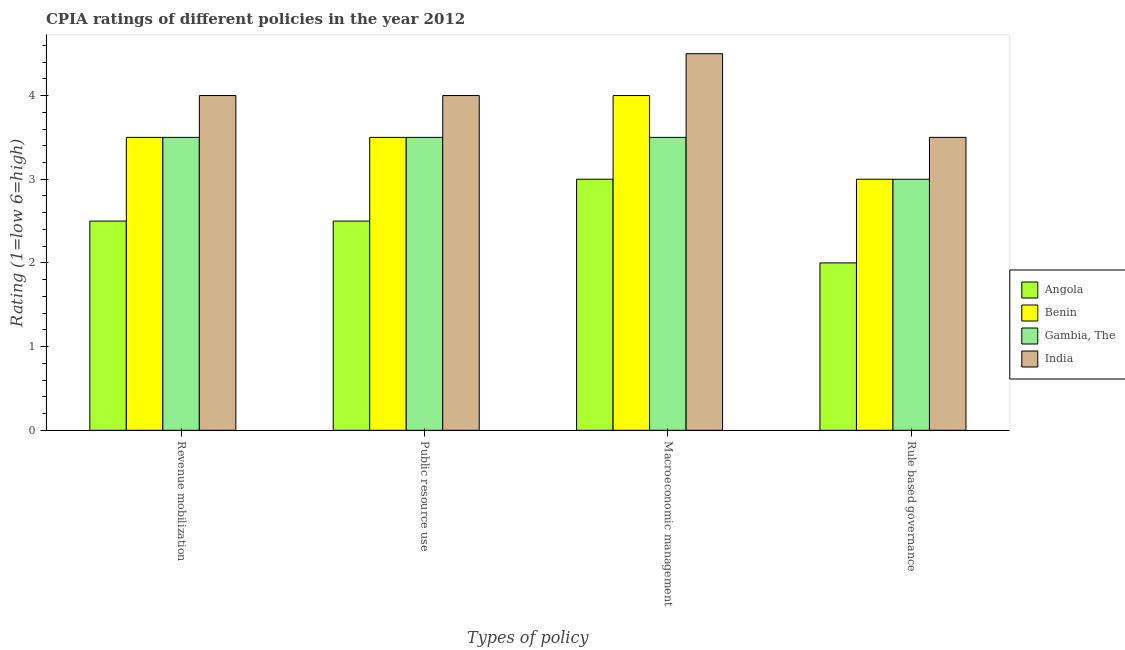How many groups of bars are there?
Your answer should be compact. 4. Are the number of bars on each tick of the X-axis equal?
Keep it short and to the point. Yes. How many bars are there on the 2nd tick from the right?
Ensure brevity in your answer.  4. What is the label of the 3rd group of bars from the left?
Make the answer very short. Macroeconomic management. Across all countries, what is the maximum cpia rating of rule based governance?
Offer a terse response. 3.5. Across all countries, what is the minimum cpia rating of macroeconomic management?
Keep it short and to the point. 3. In which country was the cpia rating of revenue mobilization maximum?
Ensure brevity in your answer.  India. In which country was the cpia rating of public resource use minimum?
Your response must be concise. Angola. What is the total cpia rating of public resource use in the graph?
Offer a terse response. 13.5. What is the difference between the cpia rating of macroeconomic management in India and that in Benin?
Offer a very short reply. 0.5. What is the average cpia rating of public resource use per country?
Ensure brevity in your answer.  3.38. What is the difference between the cpia rating of rule based governance and cpia rating of public resource use in Gambia, The?
Make the answer very short. -0.5. In how many countries, is the cpia rating of macroeconomic management greater than 1.6 ?
Keep it short and to the point. 4. What is the ratio of the cpia rating of rule based governance in India to that in Angola?
Your response must be concise. 1.75. Is the cpia rating of rule based governance in Angola less than that in Benin?
Ensure brevity in your answer.  Yes. Is the difference between the cpia rating of revenue mobilization in India and Benin greater than the difference between the cpia rating of macroeconomic management in India and Benin?
Provide a succinct answer. No. What is the difference between the highest and the second highest cpia rating of rule based governance?
Keep it short and to the point. 0.5. What is the difference between the highest and the lowest cpia rating of revenue mobilization?
Make the answer very short. 1.5. Is the sum of the cpia rating of rule based governance in India and Angola greater than the maximum cpia rating of revenue mobilization across all countries?
Offer a terse response. Yes. What does the 3rd bar from the left in Macroeconomic management represents?
Your response must be concise. Gambia, The. What does the 1st bar from the right in Rule based governance represents?
Provide a short and direct response. India. Is it the case that in every country, the sum of the cpia rating of revenue mobilization and cpia rating of public resource use is greater than the cpia rating of macroeconomic management?
Your answer should be compact. Yes. How many bars are there?
Provide a succinct answer. 16. What is the difference between two consecutive major ticks on the Y-axis?
Ensure brevity in your answer.  1. Does the graph contain any zero values?
Provide a short and direct response. No. Does the graph contain grids?
Provide a short and direct response. No. How many legend labels are there?
Provide a succinct answer. 4. How are the legend labels stacked?
Give a very brief answer. Vertical. What is the title of the graph?
Make the answer very short. CPIA ratings of different policies in the year 2012. What is the label or title of the X-axis?
Provide a succinct answer. Types of policy. What is the label or title of the Y-axis?
Give a very brief answer. Rating (1=low 6=high). What is the Rating (1=low 6=high) in Angola in Revenue mobilization?
Your answer should be compact. 2.5. What is the Rating (1=low 6=high) in Gambia, The in Revenue mobilization?
Ensure brevity in your answer.  3.5. What is the Rating (1=low 6=high) in Angola in Public resource use?
Your answer should be compact. 2.5. What is the Rating (1=low 6=high) of Benin in Public resource use?
Your answer should be very brief. 3.5. What is the Rating (1=low 6=high) of Gambia, The in Macroeconomic management?
Keep it short and to the point. 3.5. What is the Rating (1=low 6=high) of Benin in Rule based governance?
Offer a very short reply. 3. What is the Rating (1=low 6=high) of Gambia, The in Rule based governance?
Give a very brief answer. 3. Across all Types of policy, what is the maximum Rating (1=low 6=high) of Benin?
Give a very brief answer. 4. Across all Types of policy, what is the maximum Rating (1=low 6=high) in India?
Provide a short and direct response. 4.5. Across all Types of policy, what is the minimum Rating (1=low 6=high) in Benin?
Keep it short and to the point. 3. What is the total Rating (1=low 6=high) of Angola in the graph?
Offer a very short reply. 10. What is the total Rating (1=low 6=high) of Benin in the graph?
Give a very brief answer. 14. What is the total Rating (1=low 6=high) in Gambia, The in the graph?
Make the answer very short. 13.5. What is the difference between the Rating (1=low 6=high) in India in Revenue mobilization and that in Macroeconomic management?
Keep it short and to the point. -0.5. What is the difference between the Rating (1=low 6=high) in Gambia, The in Revenue mobilization and that in Rule based governance?
Your answer should be very brief. 0.5. What is the difference between the Rating (1=low 6=high) in India in Public resource use and that in Macroeconomic management?
Ensure brevity in your answer.  -0.5. What is the difference between the Rating (1=low 6=high) of Benin in Public resource use and that in Rule based governance?
Make the answer very short. 0.5. What is the difference between the Rating (1=low 6=high) in Gambia, The in Public resource use and that in Rule based governance?
Make the answer very short. 0.5. What is the difference between the Rating (1=low 6=high) in India in Public resource use and that in Rule based governance?
Provide a short and direct response. 0.5. What is the difference between the Rating (1=low 6=high) of Benin in Macroeconomic management and that in Rule based governance?
Your answer should be very brief. 1. What is the difference between the Rating (1=low 6=high) of Gambia, The in Macroeconomic management and that in Rule based governance?
Your answer should be very brief. 0.5. What is the difference between the Rating (1=low 6=high) in Angola in Revenue mobilization and the Rating (1=low 6=high) in Gambia, The in Public resource use?
Your response must be concise. -1. What is the difference between the Rating (1=low 6=high) in Benin in Revenue mobilization and the Rating (1=low 6=high) in Gambia, The in Public resource use?
Your answer should be compact. 0. What is the difference between the Rating (1=low 6=high) in Benin in Revenue mobilization and the Rating (1=low 6=high) in India in Public resource use?
Ensure brevity in your answer.  -0.5. What is the difference between the Rating (1=low 6=high) in Benin in Revenue mobilization and the Rating (1=low 6=high) in India in Macroeconomic management?
Offer a very short reply. -1. What is the difference between the Rating (1=low 6=high) of Angola in Revenue mobilization and the Rating (1=low 6=high) of Benin in Rule based governance?
Your response must be concise. -0.5. What is the difference between the Rating (1=low 6=high) of Benin in Revenue mobilization and the Rating (1=low 6=high) of Gambia, The in Rule based governance?
Give a very brief answer. 0.5. What is the difference between the Rating (1=low 6=high) in Angola in Public resource use and the Rating (1=low 6=high) in Benin in Macroeconomic management?
Offer a very short reply. -1.5. What is the difference between the Rating (1=low 6=high) in Angola in Public resource use and the Rating (1=low 6=high) in Gambia, The in Macroeconomic management?
Your answer should be compact. -1. What is the difference between the Rating (1=low 6=high) in Angola in Public resource use and the Rating (1=low 6=high) in India in Macroeconomic management?
Your answer should be very brief. -2. What is the difference between the Rating (1=low 6=high) in Angola in Public resource use and the Rating (1=low 6=high) in Gambia, The in Rule based governance?
Ensure brevity in your answer.  -0.5. What is the difference between the Rating (1=low 6=high) of Benin in Public resource use and the Rating (1=low 6=high) of Gambia, The in Rule based governance?
Offer a terse response. 0.5. What is the difference between the Rating (1=low 6=high) in Benin in Public resource use and the Rating (1=low 6=high) in India in Rule based governance?
Provide a succinct answer. 0. What is the difference between the Rating (1=low 6=high) of Gambia, The in Public resource use and the Rating (1=low 6=high) of India in Rule based governance?
Ensure brevity in your answer.  0. What is the difference between the Rating (1=low 6=high) of Angola in Macroeconomic management and the Rating (1=low 6=high) of Gambia, The in Rule based governance?
Offer a very short reply. 0. What is the difference between the Rating (1=low 6=high) in Benin in Macroeconomic management and the Rating (1=low 6=high) in Gambia, The in Rule based governance?
Give a very brief answer. 1. What is the average Rating (1=low 6=high) in Angola per Types of policy?
Make the answer very short. 2.5. What is the average Rating (1=low 6=high) in Gambia, The per Types of policy?
Ensure brevity in your answer.  3.38. What is the average Rating (1=low 6=high) of India per Types of policy?
Your response must be concise. 4. What is the difference between the Rating (1=low 6=high) of Angola and Rating (1=low 6=high) of Benin in Revenue mobilization?
Keep it short and to the point. -1. What is the difference between the Rating (1=low 6=high) in Benin and Rating (1=low 6=high) in Gambia, The in Revenue mobilization?
Make the answer very short. 0. What is the difference between the Rating (1=low 6=high) of Benin and Rating (1=low 6=high) of India in Revenue mobilization?
Make the answer very short. -0.5. What is the difference between the Rating (1=low 6=high) of Angola and Rating (1=low 6=high) of Benin in Public resource use?
Provide a short and direct response. -1. What is the difference between the Rating (1=low 6=high) of Angola and Rating (1=low 6=high) of India in Public resource use?
Provide a succinct answer. -1.5. What is the difference between the Rating (1=low 6=high) of Angola and Rating (1=low 6=high) of Benin in Macroeconomic management?
Keep it short and to the point. -1. What is the difference between the Rating (1=low 6=high) in Angola and Rating (1=low 6=high) in Gambia, The in Macroeconomic management?
Provide a short and direct response. -0.5. What is the difference between the Rating (1=low 6=high) of Angola and Rating (1=low 6=high) of India in Macroeconomic management?
Ensure brevity in your answer.  -1.5. What is the difference between the Rating (1=low 6=high) of Benin and Rating (1=low 6=high) of India in Macroeconomic management?
Your answer should be compact. -0.5. What is the difference between the Rating (1=low 6=high) in Angola and Rating (1=low 6=high) in Benin in Rule based governance?
Ensure brevity in your answer.  -1. What is the difference between the Rating (1=low 6=high) in Angola and Rating (1=low 6=high) in India in Rule based governance?
Provide a succinct answer. -1.5. What is the ratio of the Rating (1=low 6=high) of Benin in Revenue mobilization to that in Public resource use?
Your answer should be compact. 1. What is the ratio of the Rating (1=low 6=high) of India in Revenue mobilization to that in Public resource use?
Offer a terse response. 1. What is the ratio of the Rating (1=low 6=high) of Gambia, The in Revenue mobilization to that in Macroeconomic management?
Offer a terse response. 1. What is the ratio of the Rating (1=low 6=high) in Angola in Revenue mobilization to that in Rule based governance?
Keep it short and to the point. 1.25. What is the ratio of the Rating (1=low 6=high) of Benin in Revenue mobilization to that in Rule based governance?
Your response must be concise. 1.17. What is the ratio of the Rating (1=low 6=high) of Gambia, The in Revenue mobilization to that in Rule based governance?
Your answer should be compact. 1.17. What is the ratio of the Rating (1=low 6=high) in India in Revenue mobilization to that in Rule based governance?
Keep it short and to the point. 1.14. What is the ratio of the Rating (1=low 6=high) in Angola in Public resource use to that in Macroeconomic management?
Provide a succinct answer. 0.83. What is the ratio of the Rating (1=low 6=high) of Gambia, The in Public resource use to that in Macroeconomic management?
Offer a very short reply. 1. What is the ratio of the Rating (1=low 6=high) of Benin in Public resource use to that in Rule based governance?
Provide a short and direct response. 1.17. What is the ratio of the Rating (1=low 6=high) in India in Macroeconomic management to that in Rule based governance?
Offer a very short reply. 1.29. What is the difference between the highest and the second highest Rating (1=low 6=high) of India?
Keep it short and to the point. 0.5. What is the difference between the highest and the lowest Rating (1=low 6=high) in Benin?
Your response must be concise. 1. What is the difference between the highest and the lowest Rating (1=low 6=high) of India?
Offer a terse response. 1. 